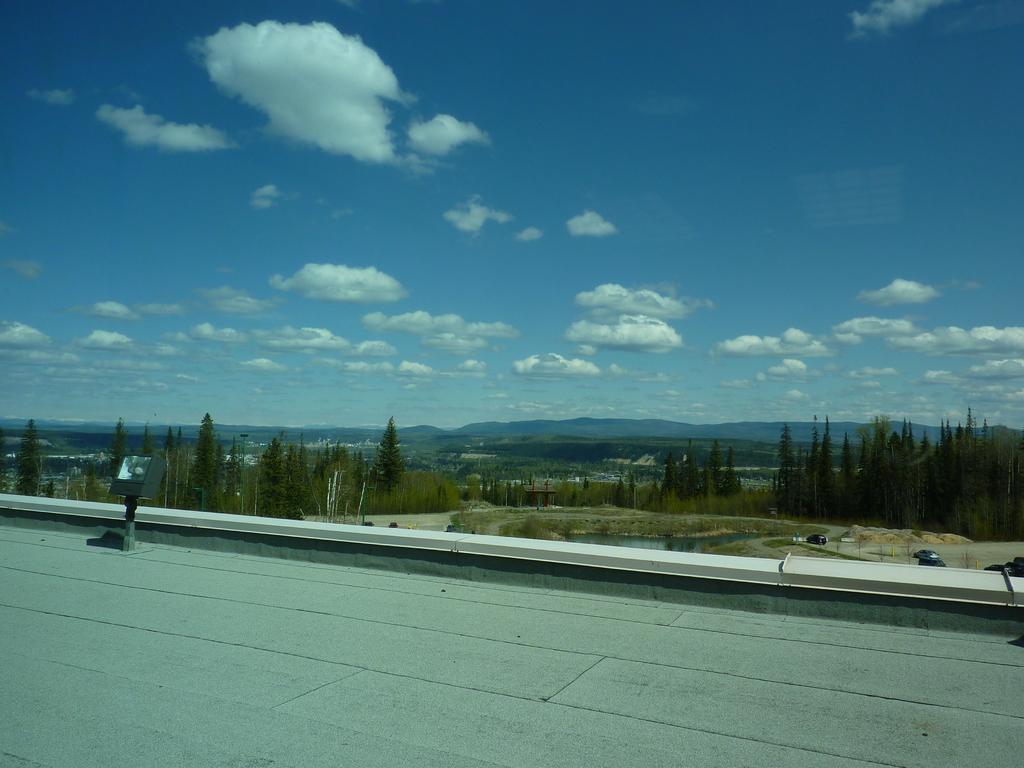In one or two sentences, can you explain what this image depicts? In this picture there are buildings and trees in the center of the image and there is sky at the top side of the image. 